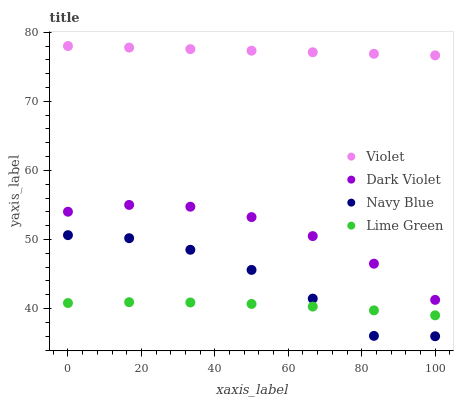Does Lime Green have the minimum area under the curve?
Answer yes or no. Yes. Does Violet have the maximum area under the curve?
Answer yes or no. Yes. Does Dark Violet have the minimum area under the curve?
Answer yes or no. No. Does Dark Violet have the maximum area under the curve?
Answer yes or no. No. Is Violet the smoothest?
Answer yes or no. Yes. Is Navy Blue the roughest?
Answer yes or no. Yes. Is Lime Green the smoothest?
Answer yes or no. No. Is Lime Green the roughest?
Answer yes or no. No. Does Navy Blue have the lowest value?
Answer yes or no. Yes. Does Lime Green have the lowest value?
Answer yes or no. No. Does Violet have the highest value?
Answer yes or no. Yes. Does Dark Violet have the highest value?
Answer yes or no. No. Is Dark Violet less than Violet?
Answer yes or no. Yes. Is Violet greater than Dark Violet?
Answer yes or no. Yes. Does Navy Blue intersect Lime Green?
Answer yes or no. Yes. Is Navy Blue less than Lime Green?
Answer yes or no. No. Is Navy Blue greater than Lime Green?
Answer yes or no. No. Does Dark Violet intersect Violet?
Answer yes or no. No. 